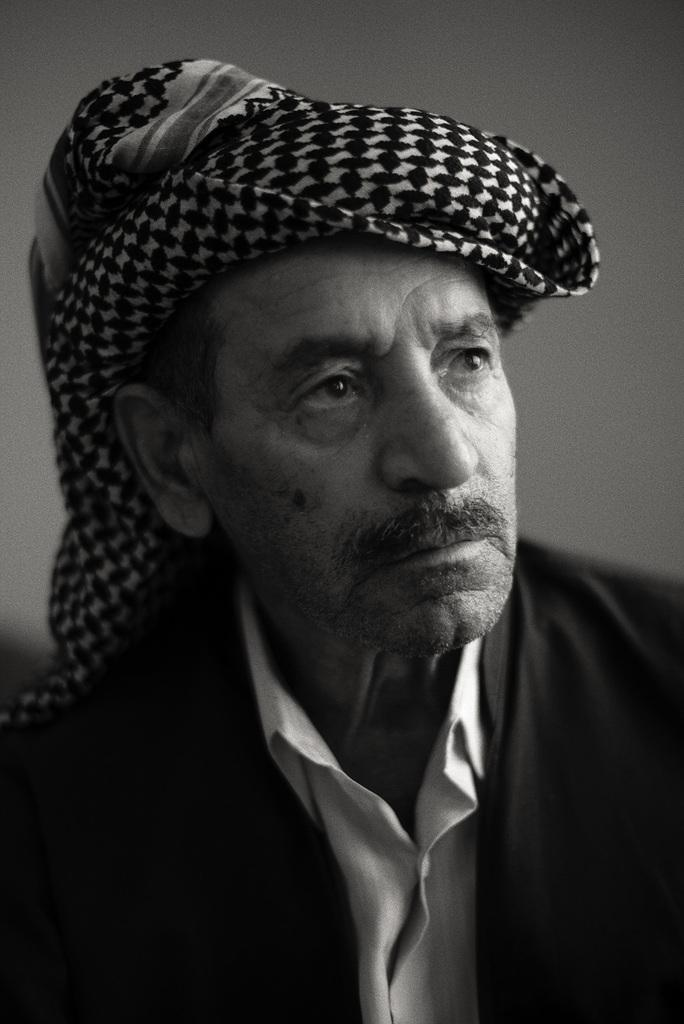Who is present in the image? There is a man in the picture. What is the man wearing in the image? The man is wearing a scarf. What is the color scheme of the image? The photography is in black and white. What type of chair is the servant sitting on in the image? There is no chair or servant present in the image; it features a man wearing a scarf in black and white photography. 